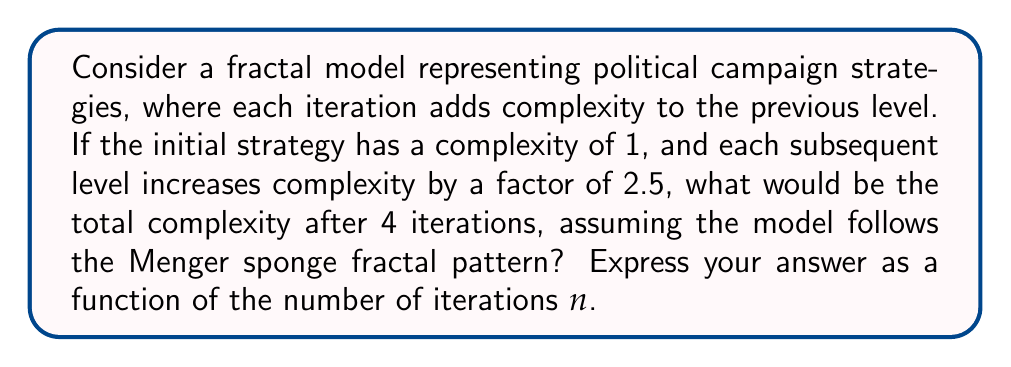Provide a solution to this math problem. Let's approach this step-by-step:

1) In a Menger sponge fractal, each iteration removes 7 out of 27 sub-cubes, leaving 20 sub-cubes.

2) The complexity factor for each iteration is 2.5.

3) Let's define the complexity function C(n) where n is the number of iterations:

   C(0) = 1 (initial complexity)
   C(n) = C(n-1) * 2.5 * (20/27) for n > 0

4) Let's calculate the first 4 iterations:

   C(1) = 1 * 2.5 * (20/27) ≈ 1.8519
   C(2) = 1.8519 * 2.5 * (20/27) ≈ 3.4295
   C(3) = 3.4295 * 2.5 * (20/27) ≈ 6.3509
   C(4) = 6.3509 * 2.5 * (20/27) ≈ 11.7609

5) We can observe that this forms a geometric sequence with common ratio 2.5 * (20/27) ≈ 1.8519.

6) The general term of a geometric sequence is given by $a_n = a_1 * r^{n-1}$, where $a_1$ is the first term and r is the common ratio.

7) In our case, $a_1 = 1 * 2.5 * (20/27)$ and $r = 2.5 * (20/27)$

8) Therefore, the general function for the complexity after n iterations is:

   $$C(n) = (2.5 * \frac{20}{27})^n$$

This function represents the total complexity after n iterations, incorporating both the increase factor and the fractal pattern.
Answer: $$C(n) = (2.5 * \frac{20}{27})^n$$ 